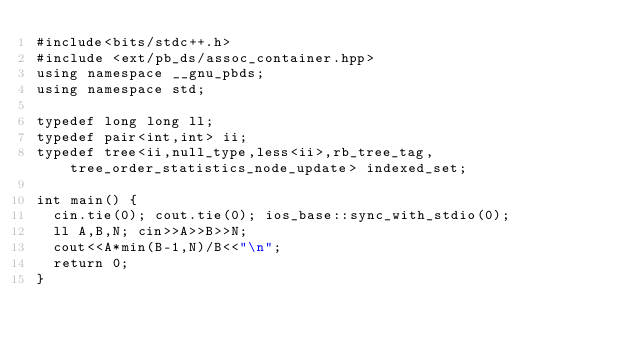<code> <loc_0><loc_0><loc_500><loc_500><_C++_>#include<bits/stdc++.h>
#include <ext/pb_ds/assoc_container.hpp>
using namespace __gnu_pbds;
using namespace std;

typedef long long ll;
typedef pair<int,int> ii;
typedef tree<ii,null_type,less<ii>,rb_tree_tag,tree_order_statistics_node_update> indexed_set;

int main() {
	cin.tie(0); cout.tie(0); ios_base::sync_with_stdio(0);
	ll A,B,N; cin>>A>>B>>N;
	cout<<A*min(B-1,N)/B<<"\n";
	return 0;
}</code> 